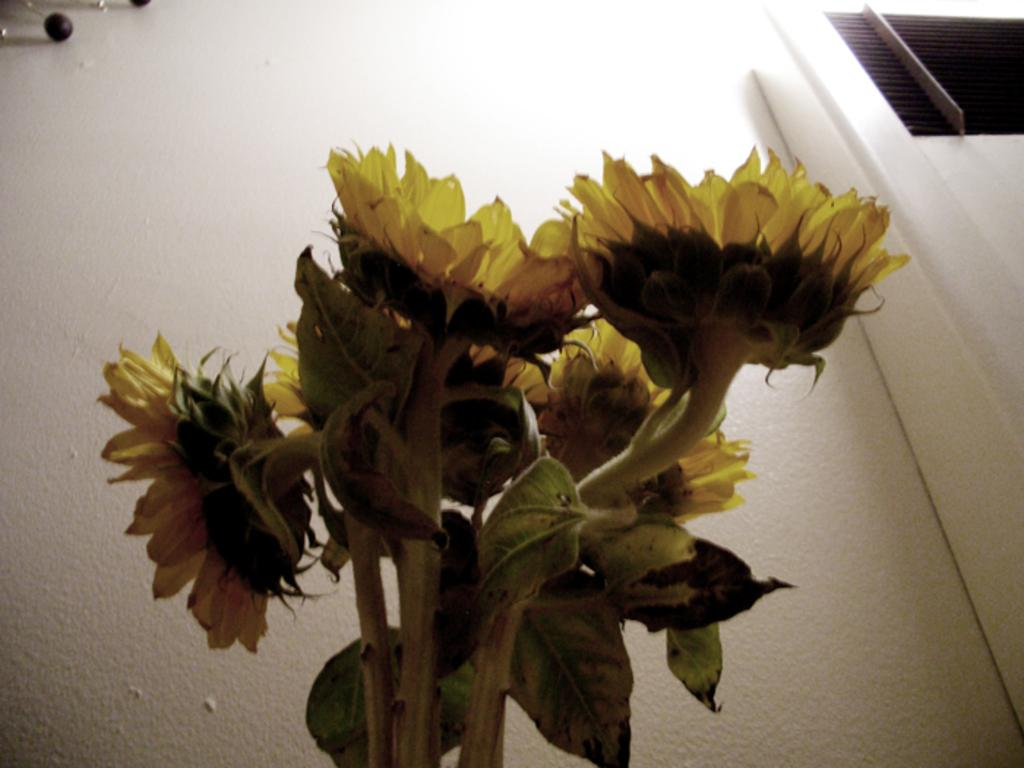What is located in the center of the image? There are flowers and leaves in the center of the image. What can be seen in the background of the image? There is a wall and a window in the background of the image. Where are the objects in the image located? The objects are in the top left corner of the image. What type of quilt is being used to cover the ice in the image? There is no quilt or ice present in the image; it features flowers and leaves in the center, a wall and window in the background, and objects in the top left corner. 